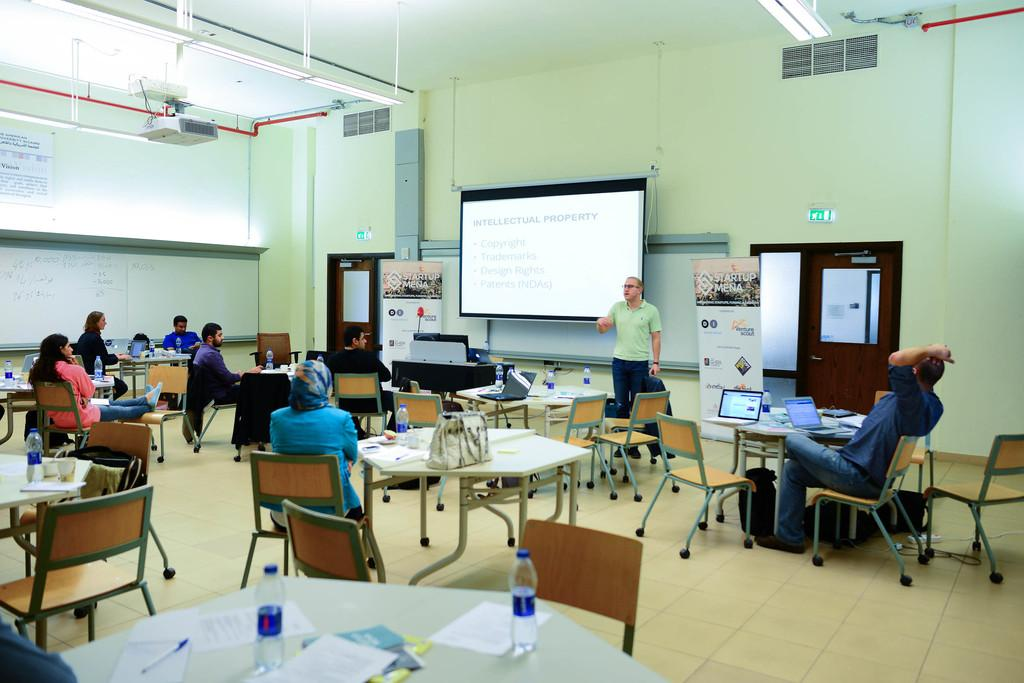What type of structure can be seen in the image? There is a wall in the image. What is present on the wall? There is a screen in the image. What architectural feature is visible in the image? There is a door in the image. What are the people in the image doing? The people are sitting in the image. What type of furniture is present in the image? There are chairs and tables in the image. What electronic devices are on the tables? There are laptops on the tables. What other items are on the tables? There are bags and bottles on the tables. Are there any plants visible in the image? There is no mention of plants in the provided facts, so we cannot determine if any are present in the image. What type of family gathering is depicted in the image? The provided facts do not mention a family gathering or any family members, so we cannot determine if one is depicted in the image. 